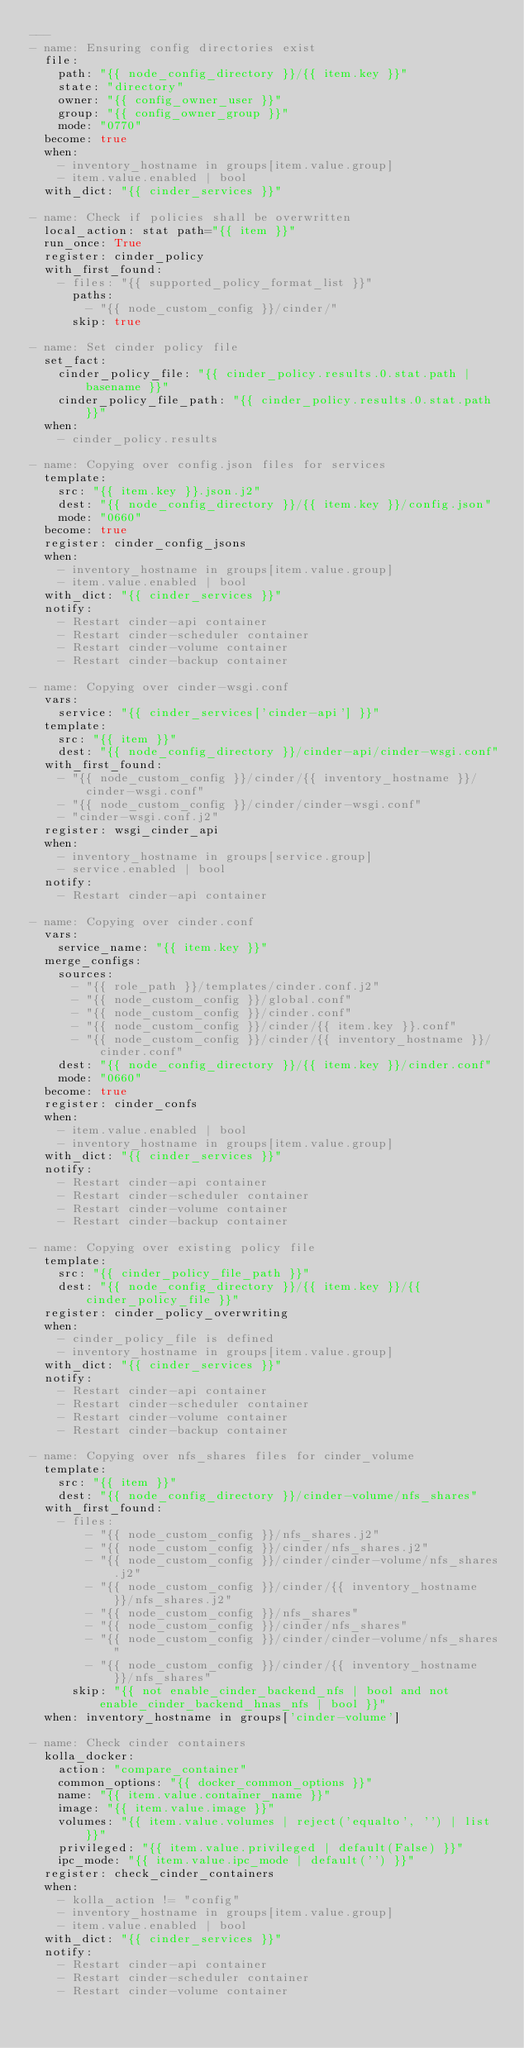Convert code to text. <code><loc_0><loc_0><loc_500><loc_500><_YAML_>---
- name: Ensuring config directories exist
  file:
    path: "{{ node_config_directory }}/{{ item.key }}"
    state: "directory"
    owner: "{{ config_owner_user }}"
    group: "{{ config_owner_group }}"
    mode: "0770"
  become: true
  when:
    - inventory_hostname in groups[item.value.group]
    - item.value.enabled | bool
  with_dict: "{{ cinder_services }}"

- name: Check if policies shall be overwritten
  local_action: stat path="{{ item }}"
  run_once: True
  register: cinder_policy
  with_first_found:
    - files: "{{ supported_policy_format_list }}"
      paths:
        - "{{ node_custom_config }}/cinder/"
      skip: true

- name: Set cinder policy file
  set_fact:
    cinder_policy_file: "{{ cinder_policy.results.0.stat.path | basename }}"
    cinder_policy_file_path: "{{ cinder_policy.results.0.stat.path }}"
  when:
    - cinder_policy.results

- name: Copying over config.json files for services
  template:
    src: "{{ item.key }}.json.j2"
    dest: "{{ node_config_directory }}/{{ item.key }}/config.json"
    mode: "0660"
  become: true
  register: cinder_config_jsons
  when:
    - inventory_hostname in groups[item.value.group]
    - item.value.enabled | bool
  with_dict: "{{ cinder_services }}"
  notify:
    - Restart cinder-api container
    - Restart cinder-scheduler container
    - Restart cinder-volume container
    - Restart cinder-backup container

- name: Copying over cinder-wsgi.conf
  vars:
    service: "{{ cinder_services['cinder-api'] }}"
  template:
    src: "{{ item }}"
    dest: "{{ node_config_directory }}/cinder-api/cinder-wsgi.conf"
  with_first_found:
    - "{{ node_custom_config }}/cinder/{{ inventory_hostname }}/cinder-wsgi.conf"
    - "{{ node_custom_config }}/cinder/cinder-wsgi.conf"
    - "cinder-wsgi.conf.j2"
  register: wsgi_cinder_api
  when:
    - inventory_hostname in groups[service.group]
    - service.enabled | bool
  notify:
    - Restart cinder-api container

- name: Copying over cinder.conf
  vars:
    service_name: "{{ item.key }}"
  merge_configs:
    sources:
      - "{{ role_path }}/templates/cinder.conf.j2"
      - "{{ node_custom_config }}/global.conf"
      - "{{ node_custom_config }}/cinder.conf"
      - "{{ node_custom_config }}/cinder/{{ item.key }}.conf"
      - "{{ node_custom_config }}/cinder/{{ inventory_hostname }}/cinder.conf"
    dest: "{{ node_config_directory }}/{{ item.key }}/cinder.conf"
    mode: "0660"
  become: true
  register: cinder_confs
  when:
    - item.value.enabled | bool
    - inventory_hostname in groups[item.value.group]
  with_dict: "{{ cinder_services }}"
  notify:
    - Restart cinder-api container
    - Restart cinder-scheduler container
    - Restart cinder-volume container
    - Restart cinder-backup container

- name: Copying over existing policy file
  template:
    src: "{{ cinder_policy_file_path }}"
    dest: "{{ node_config_directory }}/{{ item.key }}/{{ cinder_policy_file }}"
  register: cinder_policy_overwriting
  when:
    - cinder_policy_file is defined
    - inventory_hostname in groups[item.value.group]
  with_dict: "{{ cinder_services }}"
  notify:
    - Restart cinder-api container
    - Restart cinder-scheduler container
    - Restart cinder-volume container
    - Restart cinder-backup container

- name: Copying over nfs_shares files for cinder_volume
  template:
    src: "{{ item }}"
    dest: "{{ node_config_directory }}/cinder-volume/nfs_shares"
  with_first_found:
    - files:
        - "{{ node_custom_config }}/nfs_shares.j2"
        - "{{ node_custom_config }}/cinder/nfs_shares.j2"
        - "{{ node_custom_config }}/cinder/cinder-volume/nfs_shares.j2"
        - "{{ node_custom_config }}/cinder/{{ inventory_hostname }}/nfs_shares.j2"
        - "{{ node_custom_config }}/nfs_shares"
        - "{{ node_custom_config }}/cinder/nfs_shares"
        - "{{ node_custom_config }}/cinder/cinder-volume/nfs_shares"
        - "{{ node_custom_config }}/cinder/{{ inventory_hostname }}/nfs_shares"
      skip: "{{ not enable_cinder_backend_nfs | bool and not enable_cinder_backend_hnas_nfs | bool }}"
  when: inventory_hostname in groups['cinder-volume']

- name: Check cinder containers
  kolla_docker:
    action: "compare_container"
    common_options: "{{ docker_common_options }}"
    name: "{{ item.value.container_name }}"
    image: "{{ item.value.image }}"
    volumes: "{{ item.value.volumes | reject('equalto', '') | list }}"
    privileged: "{{ item.value.privileged | default(False) }}"
    ipc_mode: "{{ item.value.ipc_mode | default('') }}"
  register: check_cinder_containers
  when:
    - kolla_action != "config"
    - inventory_hostname in groups[item.value.group]
    - item.value.enabled | bool
  with_dict: "{{ cinder_services }}"
  notify:
    - Restart cinder-api container
    - Restart cinder-scheduler container
    - Restart cinder-volume container</code> 